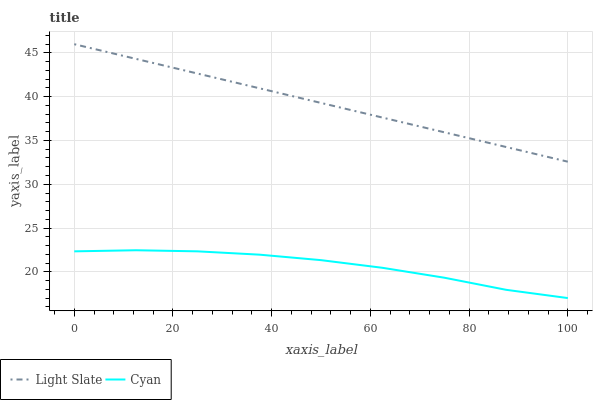Does Cyan have the minimum area under the curve?
Answer yes or no. Yes. Does Light Slate have the maximum area under the curve?
Answer yes or no. Yes. Does Cyan have the maximum area under the curve?
Answer yes or no. No. Is Light Slate the smoothest?
Answer yes or no. Yes. Is Cyan the roughest?
Answer yes or no. Yes. Is Cyan the smoothest?
Answer yes or no. No. Does Cyan have the lowest value?
Answer yes or no. Yes. Does Light Slate have the highest value?
Answer yes or no. Yes. Does Cyan have the highest value?
Answer yes or no. No. Is Cyan less than Light Slate?
Answer yes or no. Yes. Is Light Slate greater than Cyan?
Answer yes or no. Yes. Does Cyan intersect Light Slate?
Answer yes or no. No. 